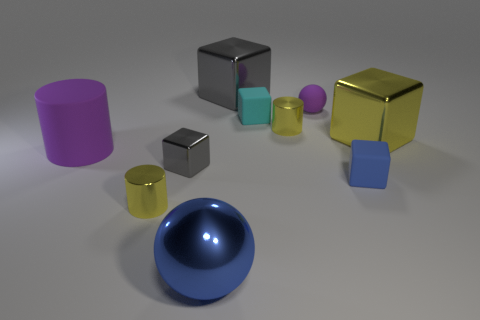Subtract all brown blocks. Subtract all cyan cylinders. How many blocks are left? 5 Subtract all balls. How many objects are left? 8 Add 9 big cyan matte cubes. How many big cyan matte cubes exist? 9 Subtract 0 green cubes. How many objects are left? 10 Subtract all small cyan blocks. Subtract all large green matte things. How many objects are left? 9 Add 1 cubes. How many cubes are left? 6 